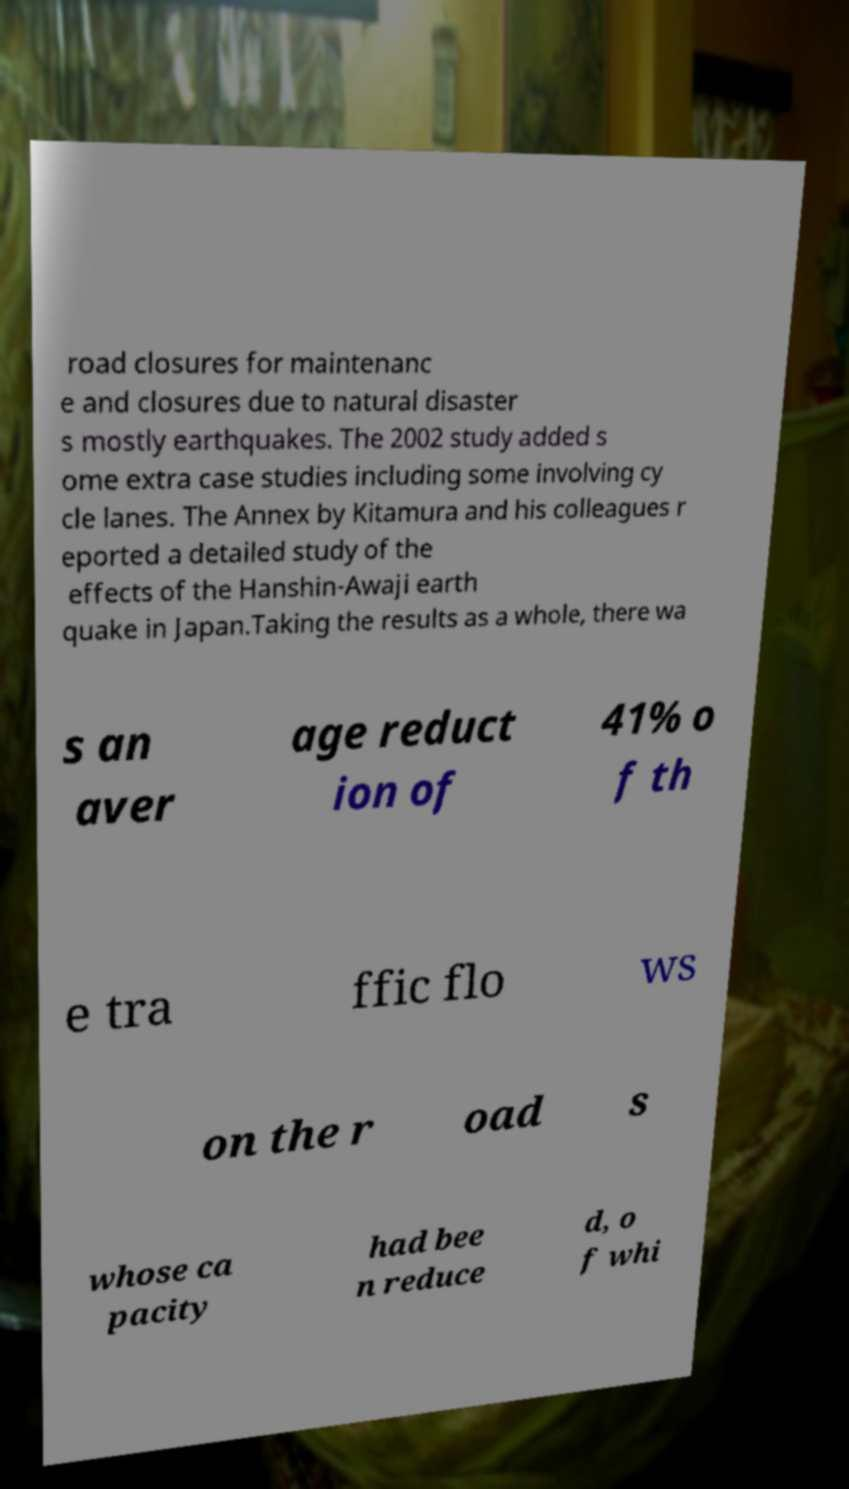Could you assist in decoding the text presented in this image and type it out clearly? road closures for maintenanc e and closures due to natural disaster s mostly earthquakes. The 2002 study added s ome extra case studies including some involving cy cle lanes. The Annex by Kitamura and his colleagues r eported a detailed study of the effects of the Hanshin-Awaji earth quake in Japan.Taking the results as a whole, there wa s an aver age reduct ion of 41% o f th e tra ffic flo ws on the r oad s whose ca pacity had bee n reduce d, o f whi 